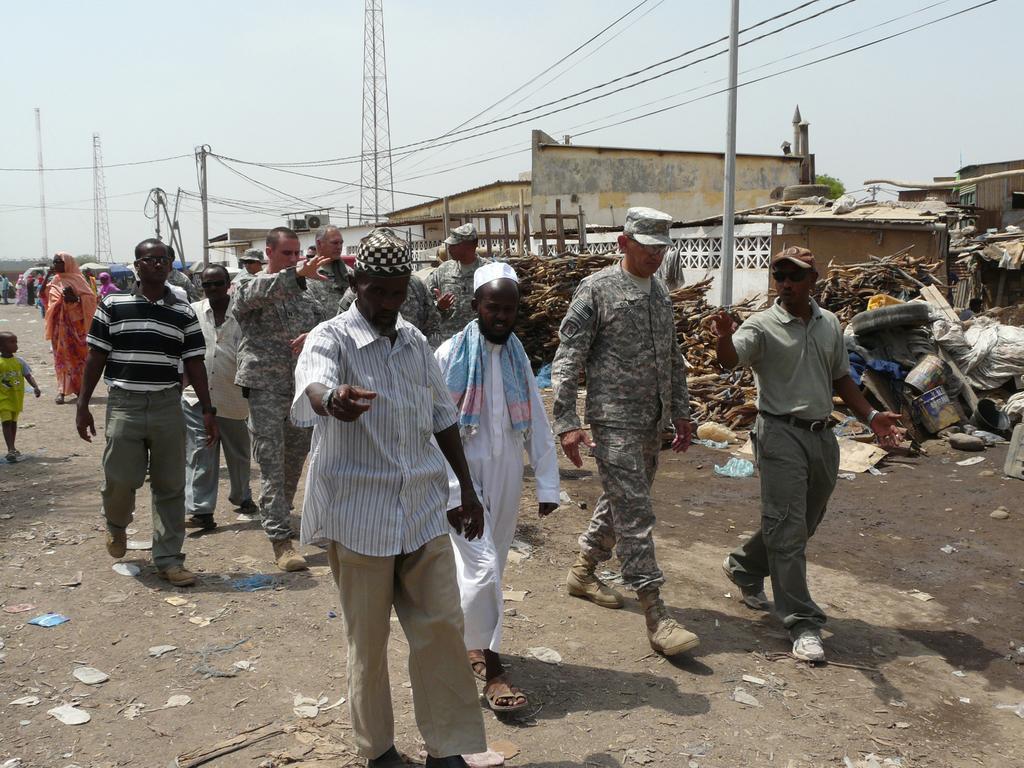Could you give a brief overview of what you see in this image? In the picture we can see some people are walking on the path of a street and beside them, we can see some scrap and poles and wires to it and in the background, we can see some buildings and behind it we can see some towers and sky. 